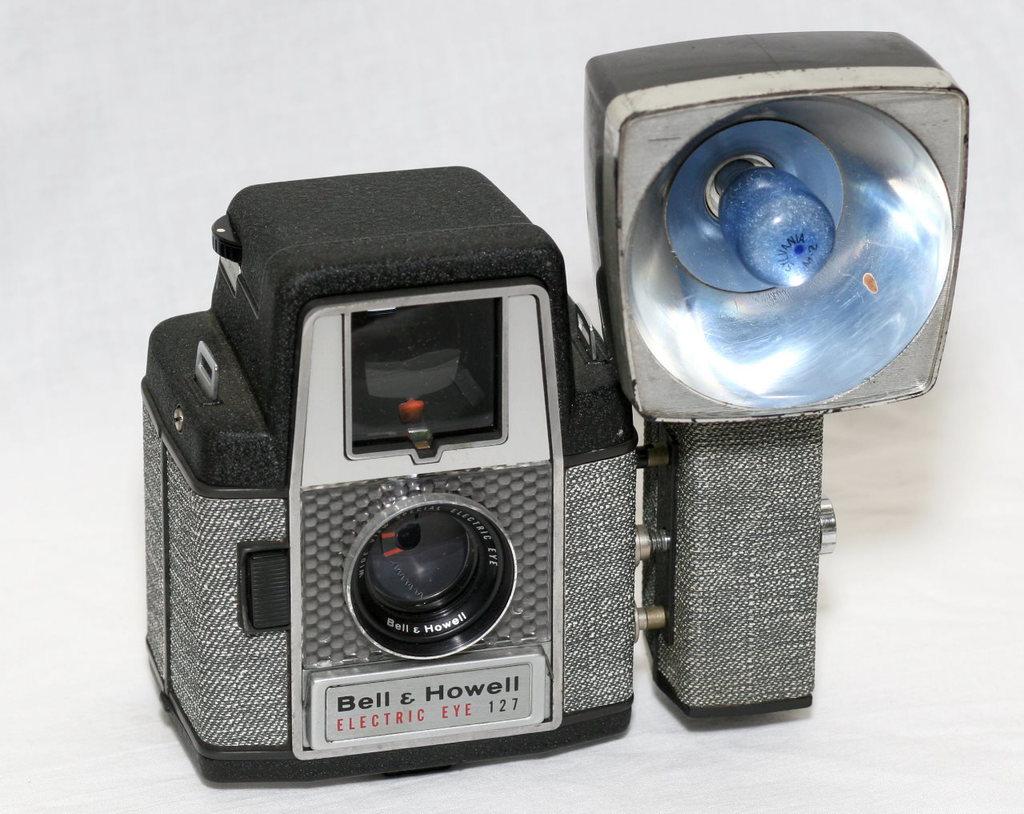What are the two names on the camera?
Offer a very short reply. Bell & howell. 